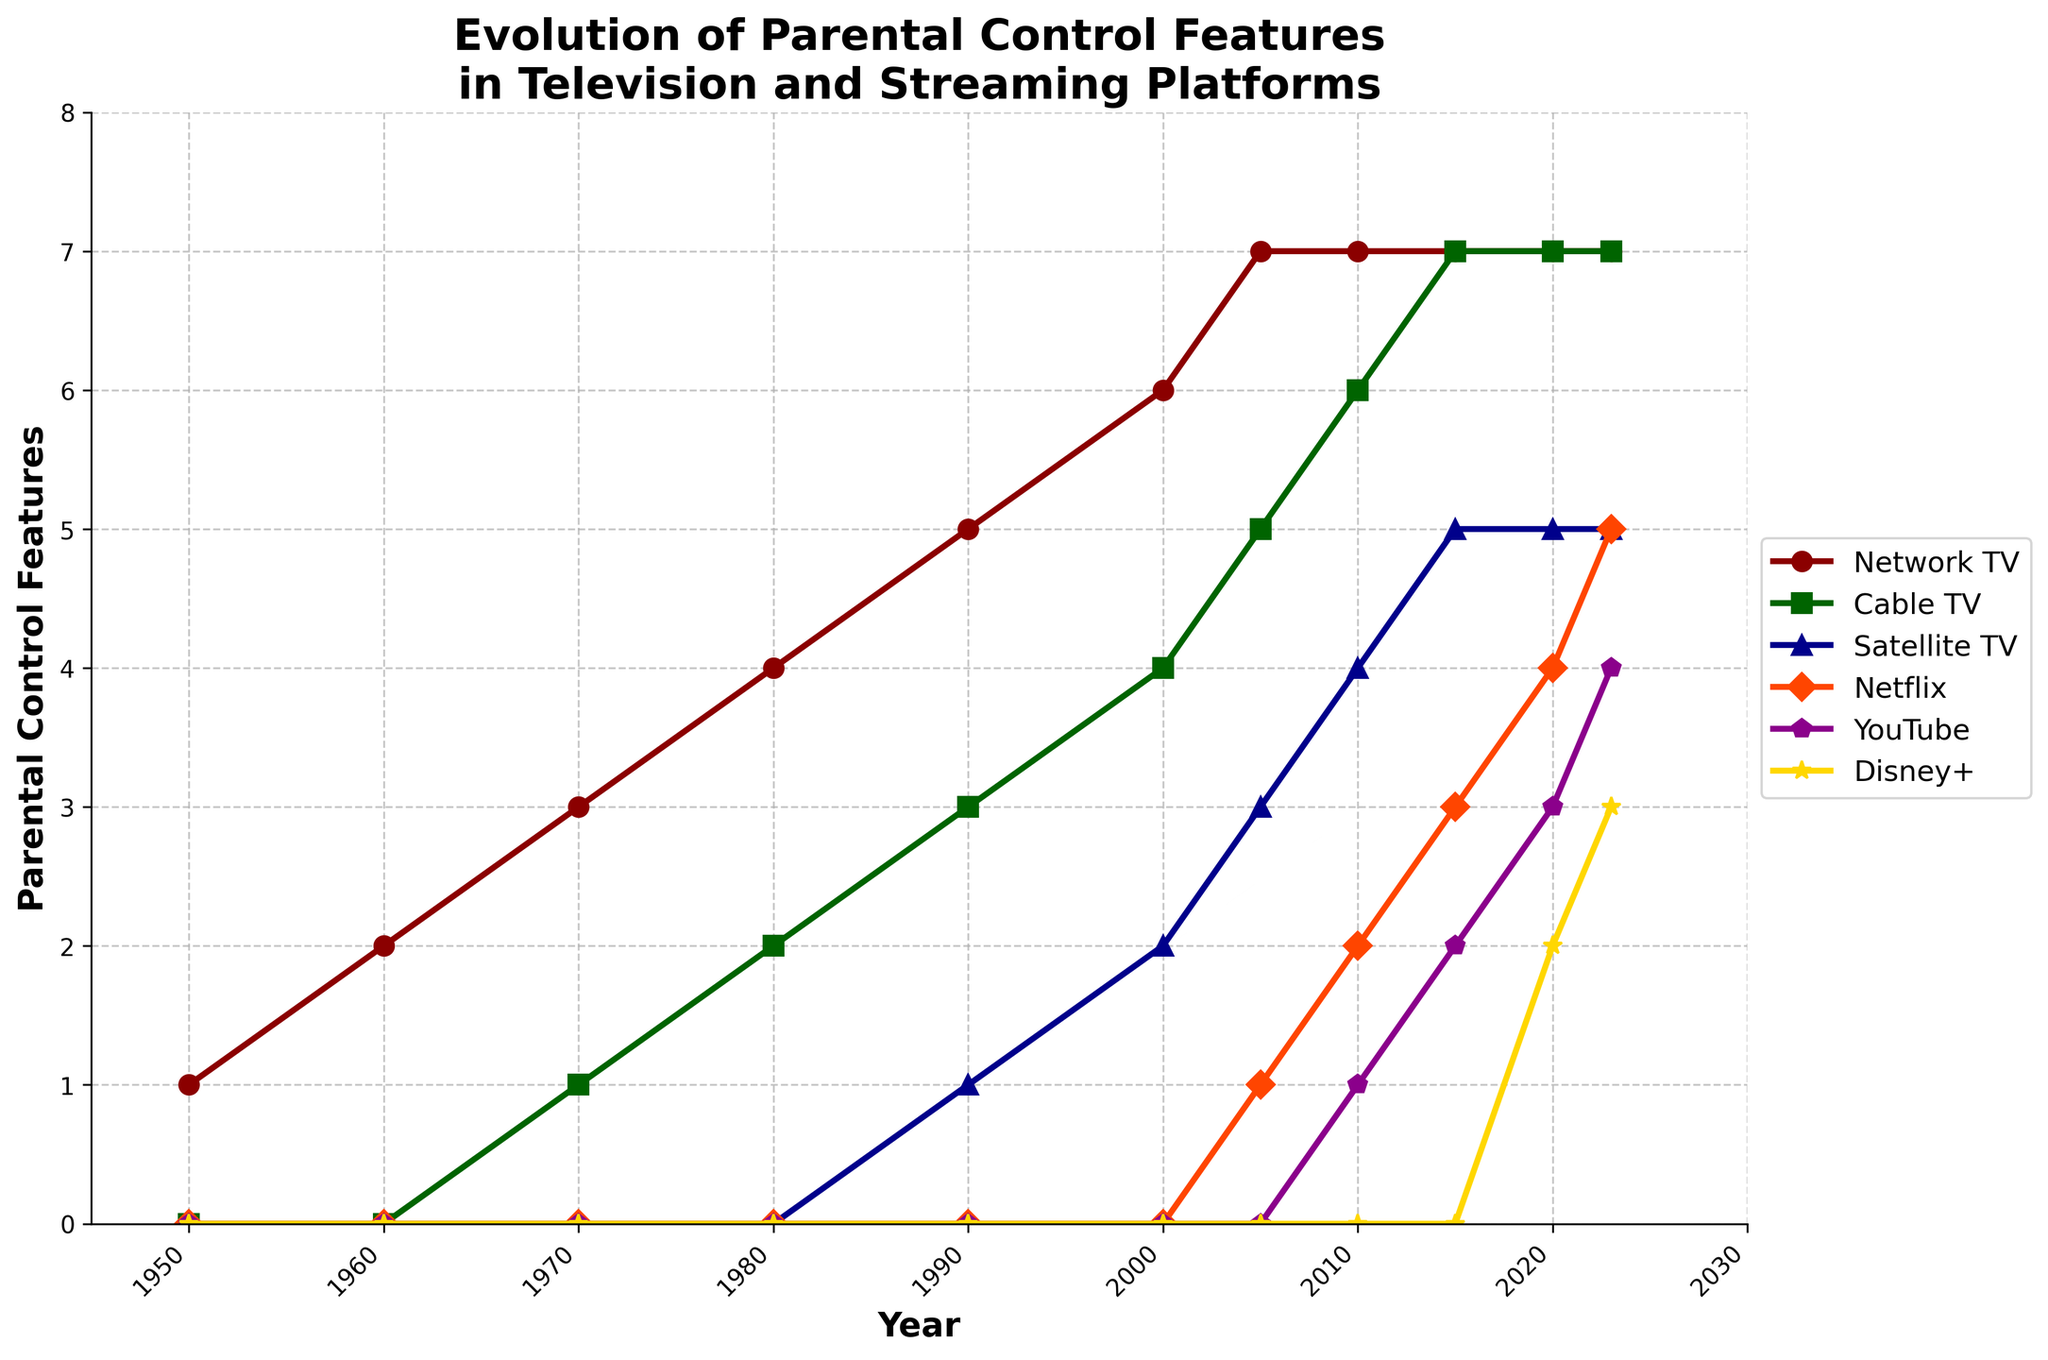How has the trend in the number of parental control features changed for Network TV from 1950 to 2023? From 1950 to 2023, the number of parental control features in Network TV increases consistently from 1 to 7 between 1950 and 2005. Between 2005 and 2023, the number remains stable at 7. Therefore, the initial increase is followed by a plateau.
Answer: Increased, then plateaued Which platform had the highest number of parental control features in 2023? In 2023, all platforms are compared, Network TV has the highest number of parental control features, which is 7.
Answer: Network TV What is the difference in the number of parental control features between Cable TV and Disney+ in 2023? In 2023, Cable TV has 7 parental control features, and Disney+ has 3 parental control features. The difference is calculated as 7 - 3 = 4.
Answer: 4 Between 2000 and 2010, which platform saw the introduction of parental control features? By comparing the trends from the figure, it is seen that Netflix introduced its parental control features between 2000 and 2010, going from 0 to 2 features.
Answer: Netflix Calculate the average number of parental control features for Satellite TV in the years where data is available. The data for Satellite TV is available for years 1990, 2000, 2005, 2010, 2015, 2020, and 2023 with the values 1, 2, 3, 4, 5, 5, and 5 respectively. The sum of these values is 25, and there are 7 data points, so the average is 25 / 7 = ~3.57.
Answer: ~3.57 During which decade did Network TV experience the most growth in parental control features? To determine this, compare the increases in each decade: From 1950-1960 (+1), 1960-1970 (+1), 1970-1980 (+1), 1980-1990 (+1), 1990-2000 (+1), and 2000-2010 (+1). Network TV saw equal growth each decade, with +1 feature every decade until 1990, followed by +1 in the next two decades. Hence, the most growth was consistent.
Answer: Each decade until 1990 Which platform showed a steady increase in parental control features every decade since their introduction? Referring to the increments in each decade for all platforms, YouTube showed a steady increase: 2010 (1), 2015 (2), 2020 (3), 2023 (4). Thus, YouTube increases steadily.
Answer: YouTube How many platforms had zero parental control features in 2000? Observing the year 2000, Network TV (6), Cable TV (4), Satellite TV (2), and Netflix (0), no values for YouTube and Disney+. Therefore, YouTube and Disney+ had zero features in 2000, as they were not introduced yet.
Answer: 2 